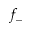Convert formula to latex. <formula><loc_0><loc_0><loc_500><loc_500>f _ { - }</formula> 